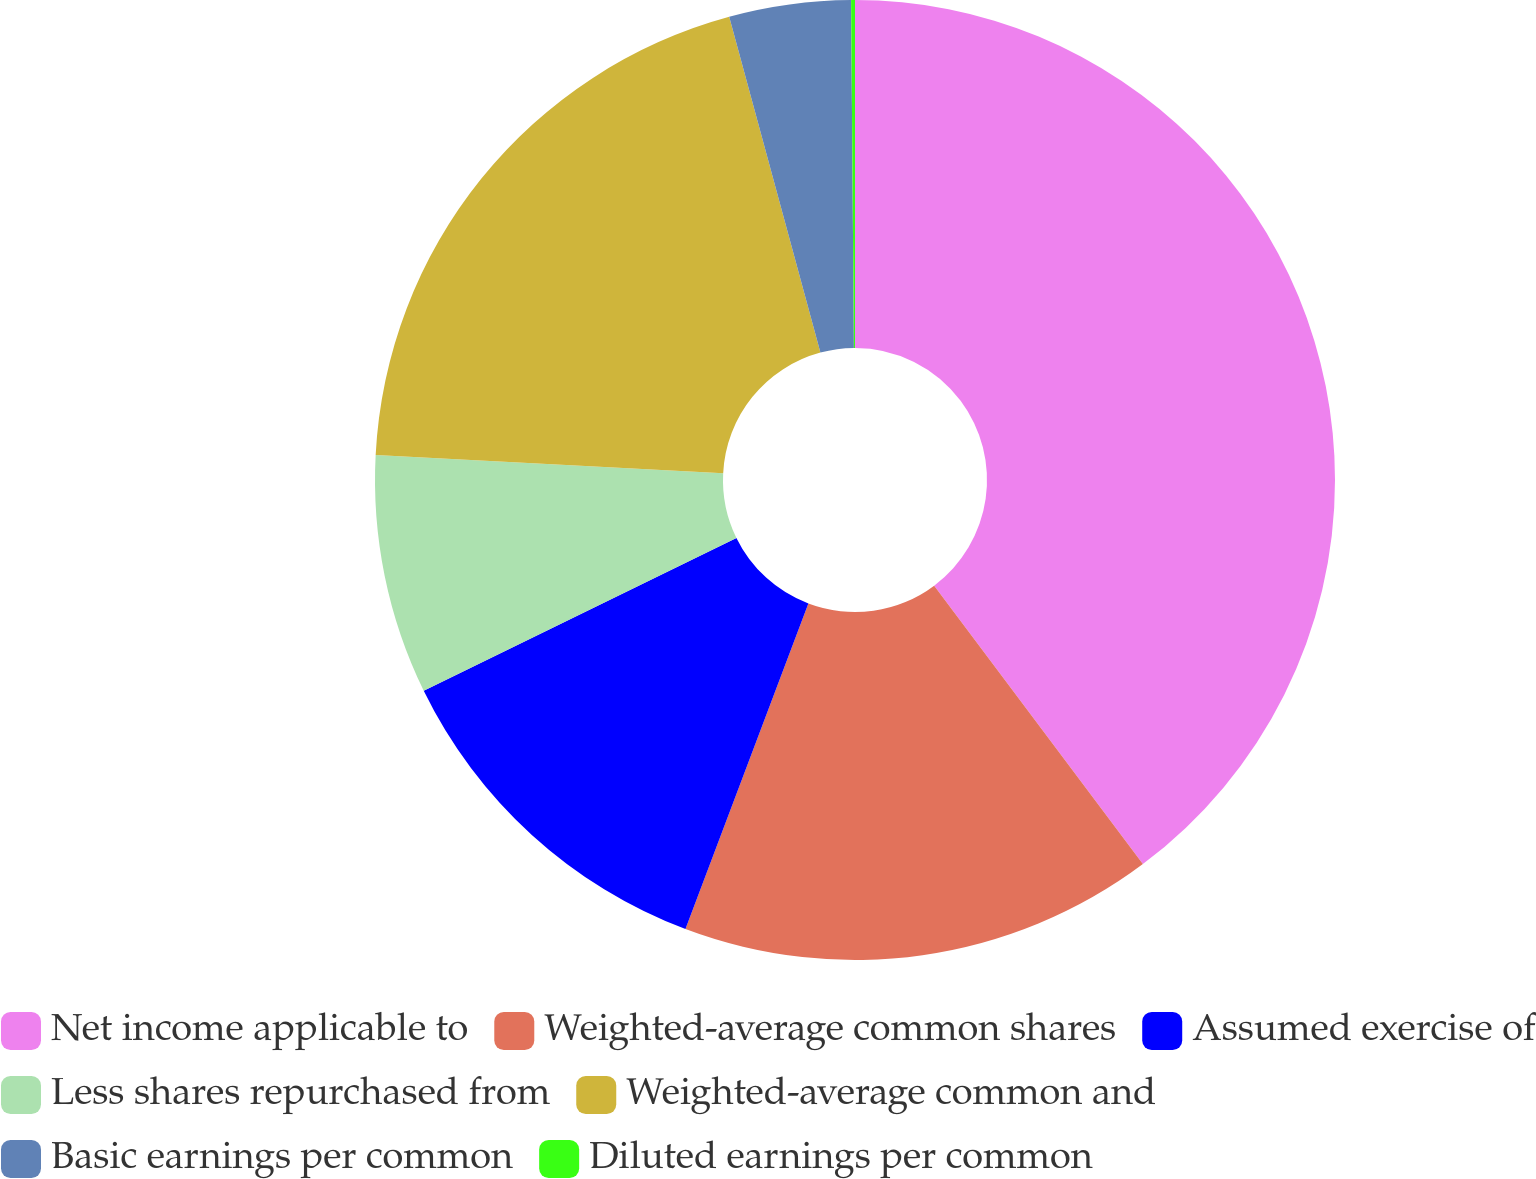Convert chart to OTSL. <chart><loc_0><loc_0><loc_500><loc_500><pie_chart><fcel>Net income applicable to<fcel>Weighted-average common shares<fcel>Assumed exercise of<fcel>Less shares repurchased from<fcel>Weighted-average common and<fcel>Basic earnings per common<fcel>Diluted earnings per common<nl><fcel>39.76%<fcel>15.98%<fcel>12.02%<fcel>8.06%<fcel>19.95%<fcel>4.09%<fcel>0.13%<nl></chart> 